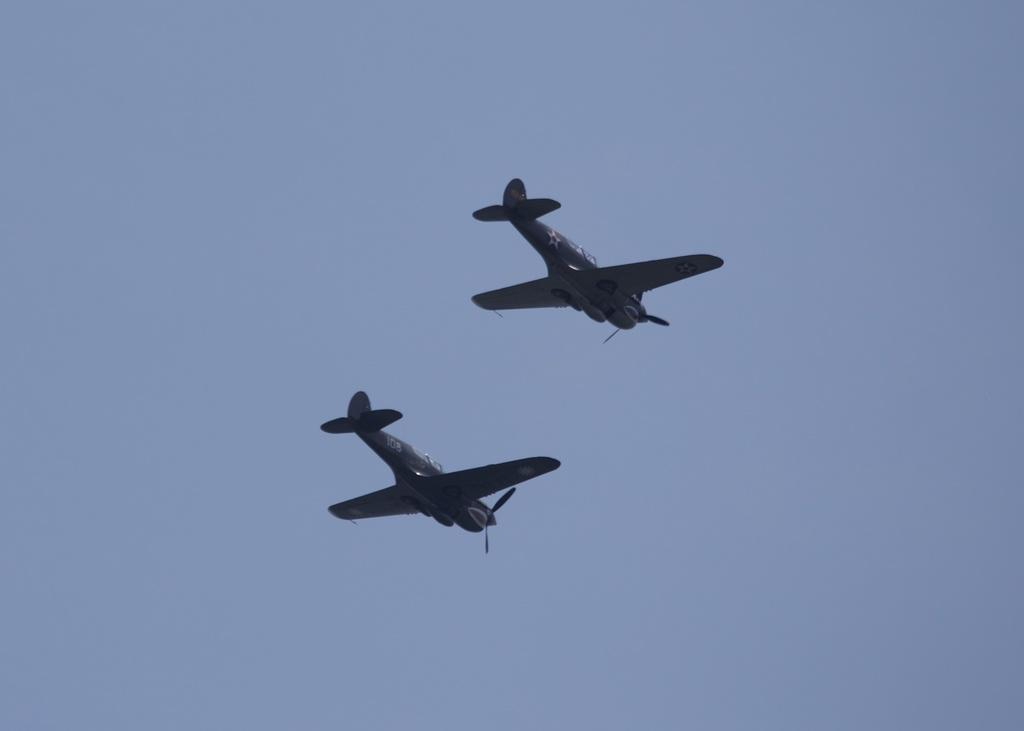What is the main subject of the image? The main subject of the image is aeroplanes. Where are the aeroplanes located in the image? The aeroplanes are in the air in the image. What is the fifth aeroplane doing in the image? There is no mention of a fifth aeroplane in the image, and therefore no such activity can be observed. 